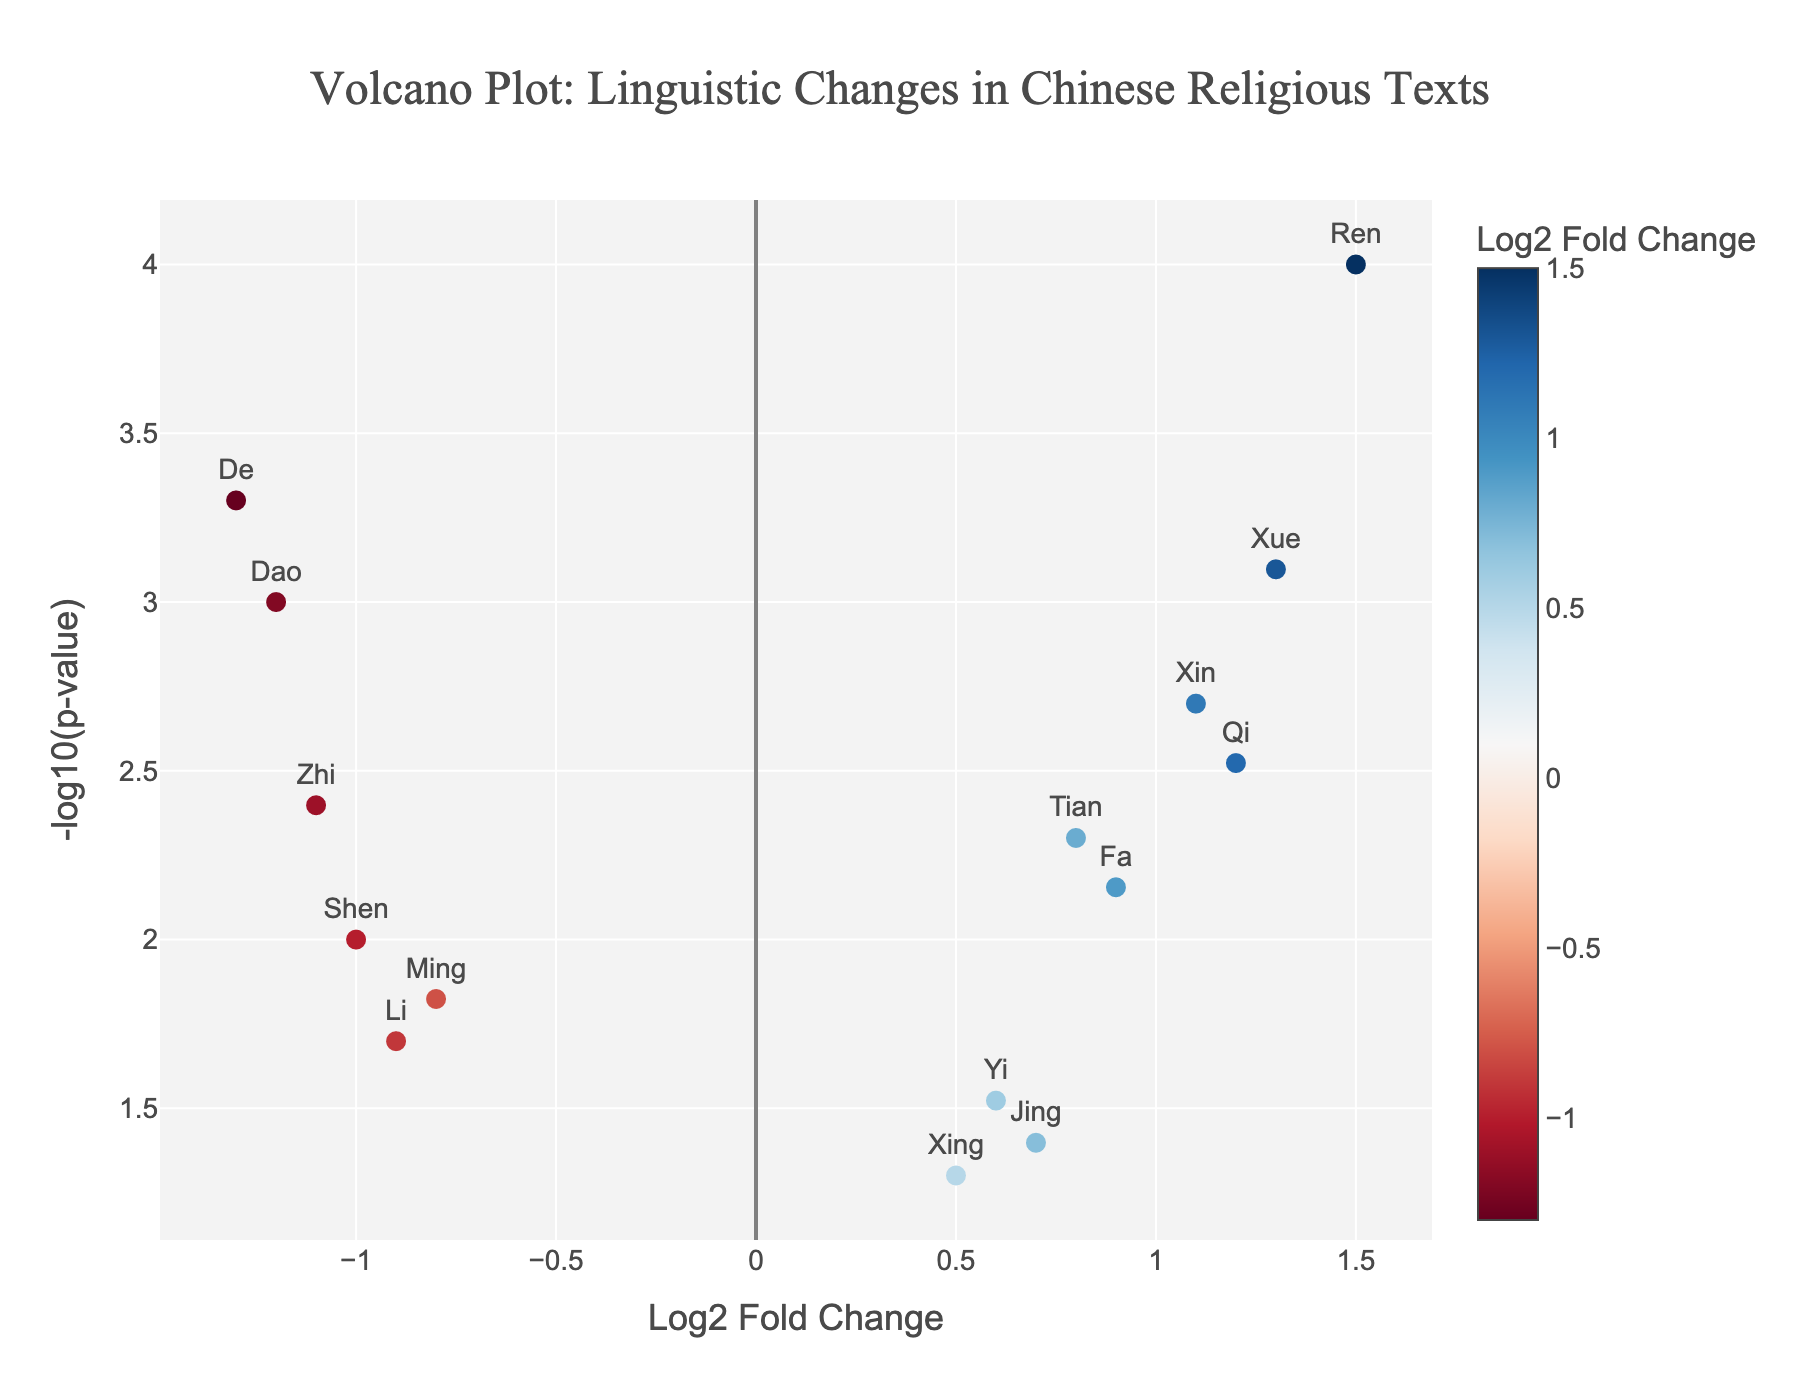What does the title of the figure represent? The title of the figure is "Volcano Plot: Linguistic Changes in Chinese Religious Texts," indicating that the plot visualizes changes in terminology frequency across different periods in Chinese religious texts.
Answer: Volcano Plot: Linguistic Changes in Chinese Religious Texts What does the x-axis represent? The x-axis is labeled "Log2 Fold Change," which represents the log2-transformed fold change in term frequencies between different periods of the studied texts.
Answer: Log2 Fold Change What does the y-axis represent? The y-axis is labeled "-log10(p-value)," representing the negative log10-transformed p-values of the statistical tests comparing term frequencies.
Answer: -log10(p-value) Which term has the highest -log10(p-value)? By examining the position on the y-axis, the term "Ren" has the highest -log10(p-value).
Answer: Ren Which term shows the greatest increase in frequency over time? The term "Ren", with the highest positive Log2FoldChange (1.5), shows the greatest increase.
Answer: Ren Which term is the most statistically significant? The smallest p-value corresponds to the highest -log10(p-value). Thus, "Ren" is the most statistically significant.
Answer: Ren What are the color differences indicating in this plot? The colors correspond to the Log2FoldChange values, with a color scale indicating varying levels of fold changes.
Answer: Indicating levels of fold changes Which term is closest to the x-axis origin (log2 fold change = 0)? The term "Xing" is closest to the origin, indicating minimal change in frequency.
Answer: Xing How many terms have a negative Log2FoldChange value? By counting the data points with negative x-axis values (Dao, Li, De, Shen, Ming, Zhi), there are six terms with a negative Log2FoldChange.
Answer: Six Between the terms "Qi" and "Fa," which has a higher -log10(p-value)? The term "Qi" is higher on the y-axis than "Fa," indicating a higher -log10(p-value).
Answer: Qi 